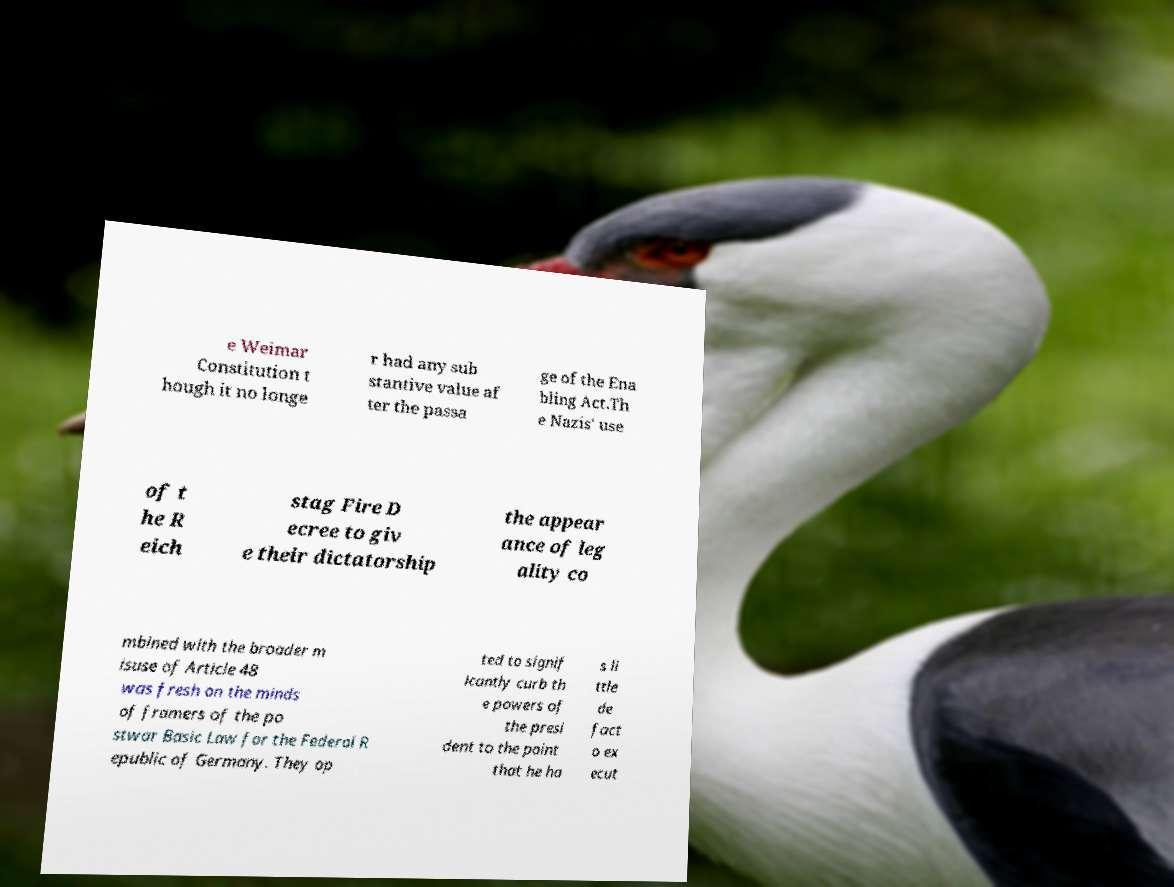Can you read and provide the text displayed in the image?This photo seems to have some interesting text. Can you extract and type it out for me? e Weimar Constitution t hough it no longe r had any sub stantive value af ter the passa ge of the Ena bling Act.Th e Nazis' use of t he R eich stag Fire D ecree to giv e their dictatorship the appear ance of leg ality co mbined with the broader m isuse of Article 48 was fresh on the minds of framers of the po stwar Basic Law for the Federal R epublic of Germany. They op ted to signif icantly curb th e powers of the presi dent to the point that he ha s li ttle de fact o ex ecut 